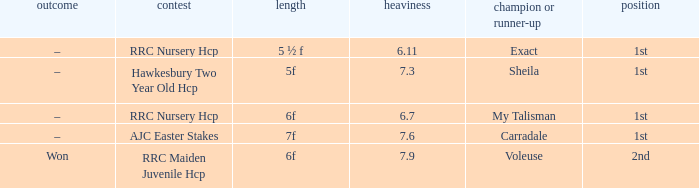What is the the name of the winner or 2nd  with a weight more than 7.3, and the result was –? Carradale. 